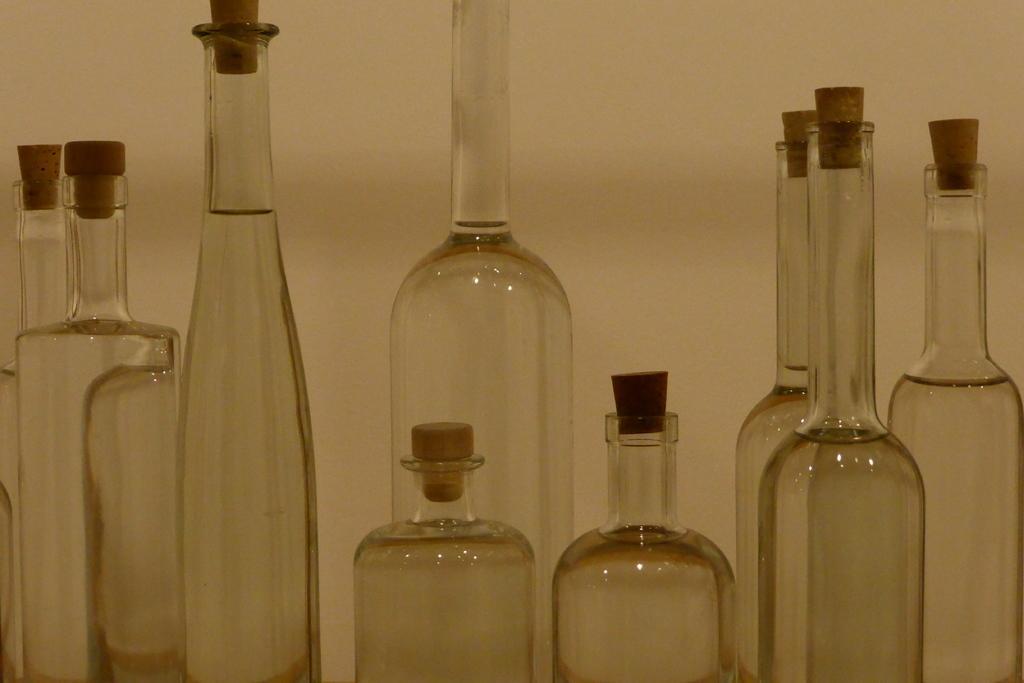In one or two sentences, can you explain what this image depicts? This is a picture of empty bottles with the wooden lid at the back ground we have a wall. 